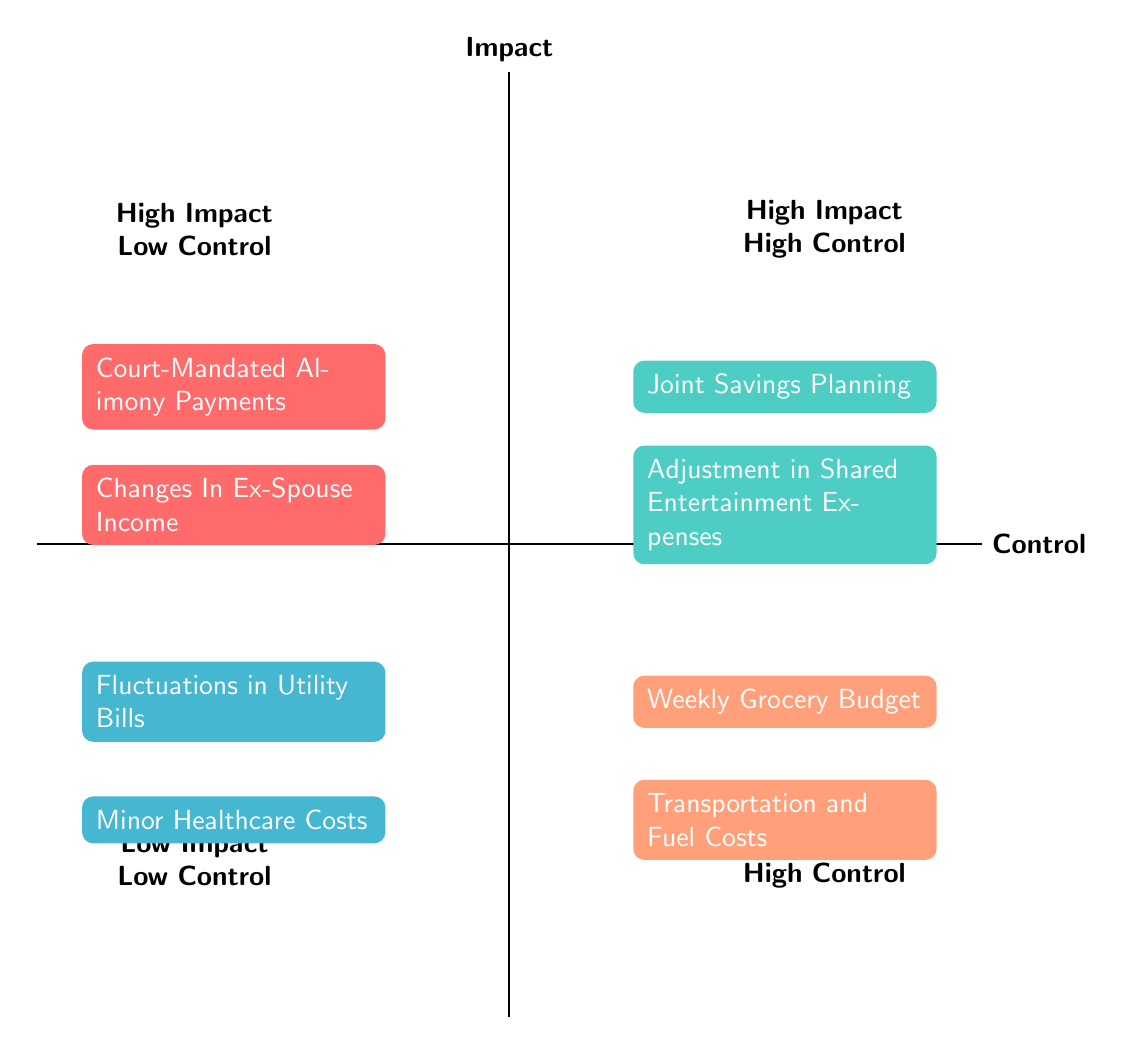What's in the "High Impact, Low Control" quadrant? The "High Impact, Low Control" quadrant contains the nodes labeled "Court-Mandated Alimony Payments" and "Changes In Ex-Spouse Income." By referring to the diagram, we can directly read the components listed in this quadrant.
Answer: Court-Mandated Alimony Payments, Changes In Ex-Spouse Income How many items are there in the "Low Impact, High Control" quadrant? The "Low Impact, High Control" quadrant includes two items: "Weekly Grocery Budget" and "Transportation and Fuel Costs." Counting these items gives us a total of two.
Answer: 2 What node indicates high control and high impact? The high control and high impact node is "Joint Savings Planning." This can be identified from the position of this node in the "High Impact, High Control" quadrant.
Answer: Joint Savings Planning What are the characteristics of nodes in the "Low Impact, Low Control" quadrant? The "Low Impact, Low Control" quadrant features nodes that represent minor expenses that cannot be easily controlled, such as "Fluctuations in Utility Bills" and "Minor Healthcare Costs." This information can be observed by examining the descriptions of nodes in that quadrant.
Answer: Fluctuations in Utility Bills, Minor Healthcare Costs Which items fall into the "High Impact, Low Control" category and relate to alimony? The items that fall into this category and relate to alimony are "Court-Mandated Alimony Payments" and "Changes In Ex-Spouse Income," both of which directly affect the financial situation surrounding alimony. The interplay between the impact and control concerning alimony can be derived from the diagram.
Answer: Court-Mandated Alimony Payments, Changes In Ex-Spouse Income 